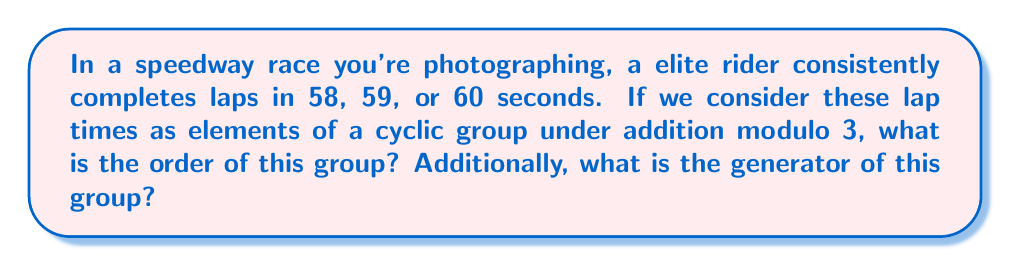Give your solution to this math problem. Let's approach this step-by-step:

1) First, we need to map the lap times to elements in $\mathbb{Z}_3$ (integers modulo 3):
   58 seconds ≡ 1 (mod 3)
   59 seconds ≡ 2 (mod 3)
   60 seconds ≡ 0 (mod 3)

2) So, our group elements are {0, 1, 2} under addition modulo 3.

3) To determine if this is a cyclic group, we need to check if there's an element that generates all other elements through repeated addition.

4) Let's check each element:
   For 0: 0, 0+0=0, 0+0+0=0 (doesn't generate all elements)
   For 1: 1, 1+1=2, 1+1+1=0 (generates all elements)
   For 2: 2, 2+2=1, 2+2+2=0 (generates all elements)

5) Since we found elements that generate all others, this is indeed a cyclic group.

6) The order of a group is the number of elements in the group. Here, we have 3 elements: {0, 1, 2}.

7) A generator of a cyclic group is an element that, when repeatedly applied (added in this case), generates all elements of the group. From step 4, we see that both 1 and 2 are generators.
Answer: The order of the group is 3, and the generators of the group are 1 and 2 (corresponding to lap times of 58 and 59 seconds respectively). 